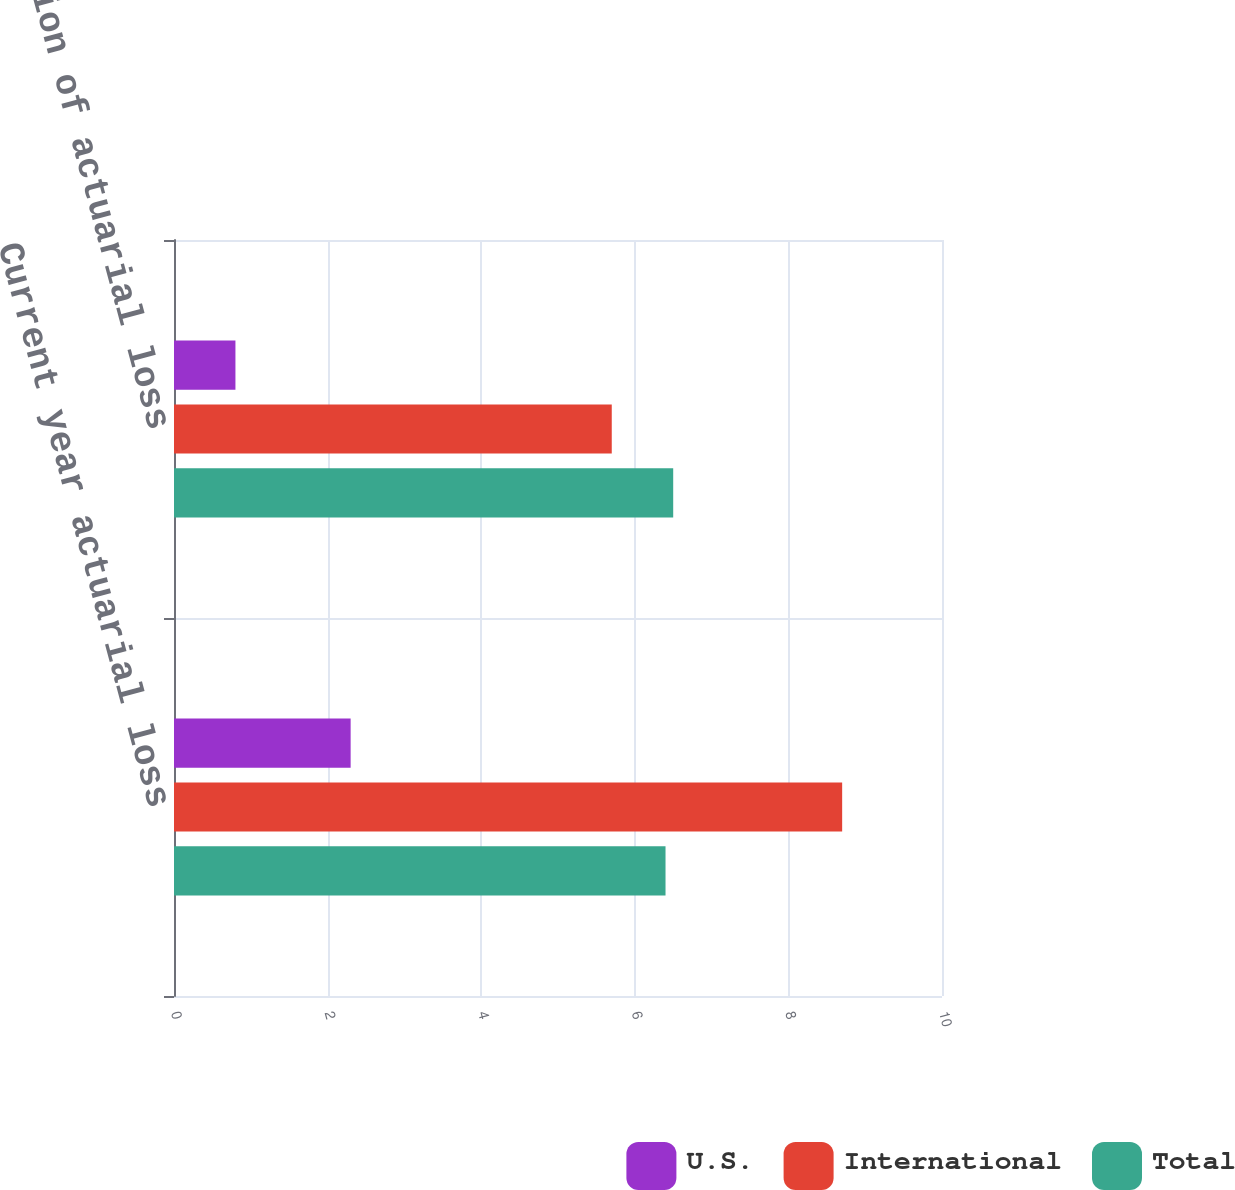Convert chart. <chart><loc_0><loc_0><loc_500><loc_500><stacked_bar_chart><ecel><fcel>Current year actuarial loss<fcel>Amortization of actuarial loss<nl><fcel>U.S.<fcel>2.3<fcel>0.8<nl><fcel>International<fcel>8.7<fcel>5.7<nl><fcel>Total<fcel>6.4<fcel>6.5<nl></chart> 